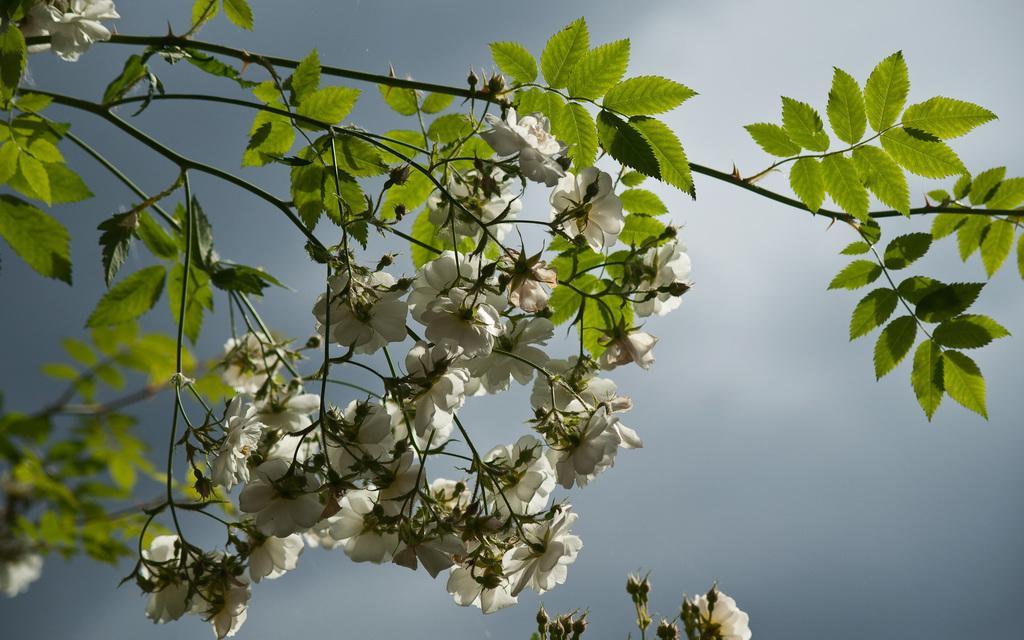Describe this image in one or two sentences. In this image I can see a tree which is green in color and few flowers which are white in color. In the background I can see the sky. 